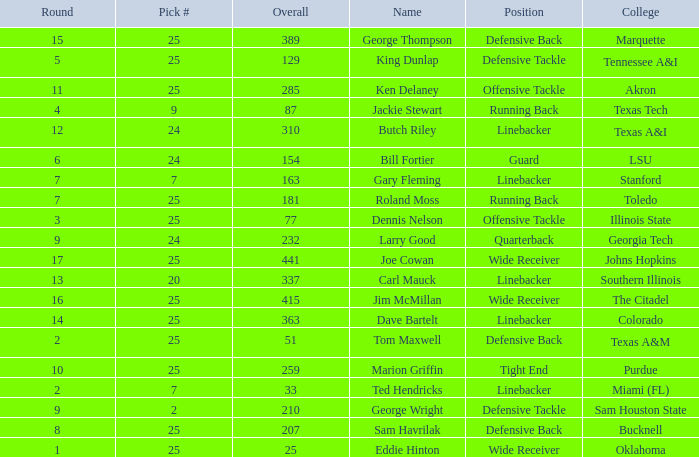Pick # of 25, and an Overall of 207 has what name? Sam Havrilak. 